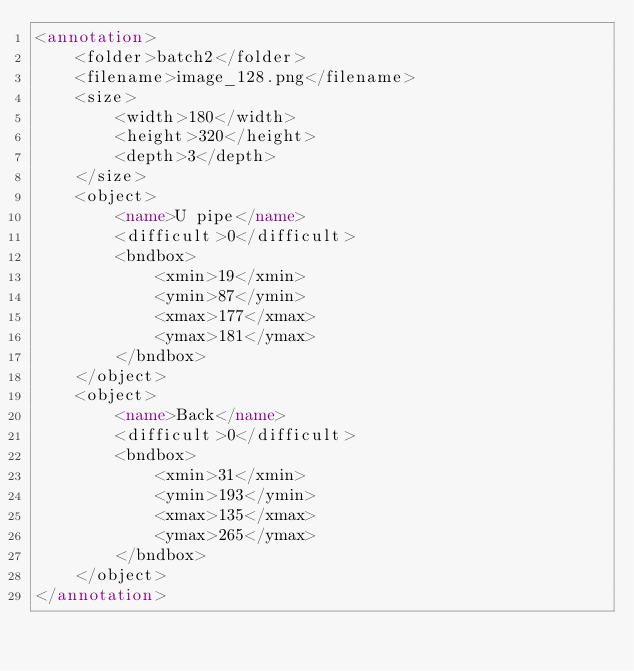Convert code to text. <code><loc_0><loc_0><loc_500><loc_500><_XML_><annotation>
    <folder>batch2</folder>
    <filename>image_128.png</filename>
    <size>
        <width>180</width>
        <height>320</height>
        <depth>3</depth>
    </size>
    <object>
        <name>U pipe</name>
        <difficult>0</difficult>
        <bndbox>
            <xmin>19</xmin>
            <ymin>87</ymin>
            <xmax>177</xmax>
            <ymax>181</ymax>
        </bndbox>
    </object>
    <object>
        <name>Back</name>
        <difficult>0</difficult>
        <bndbox>
            <xmin>31</xmin>
            <ymin>193</ymin>
            <xmax>135</xmax>
            <ymax>265</ymax>
        </bndbox>
    </object>
</annotation></code> 